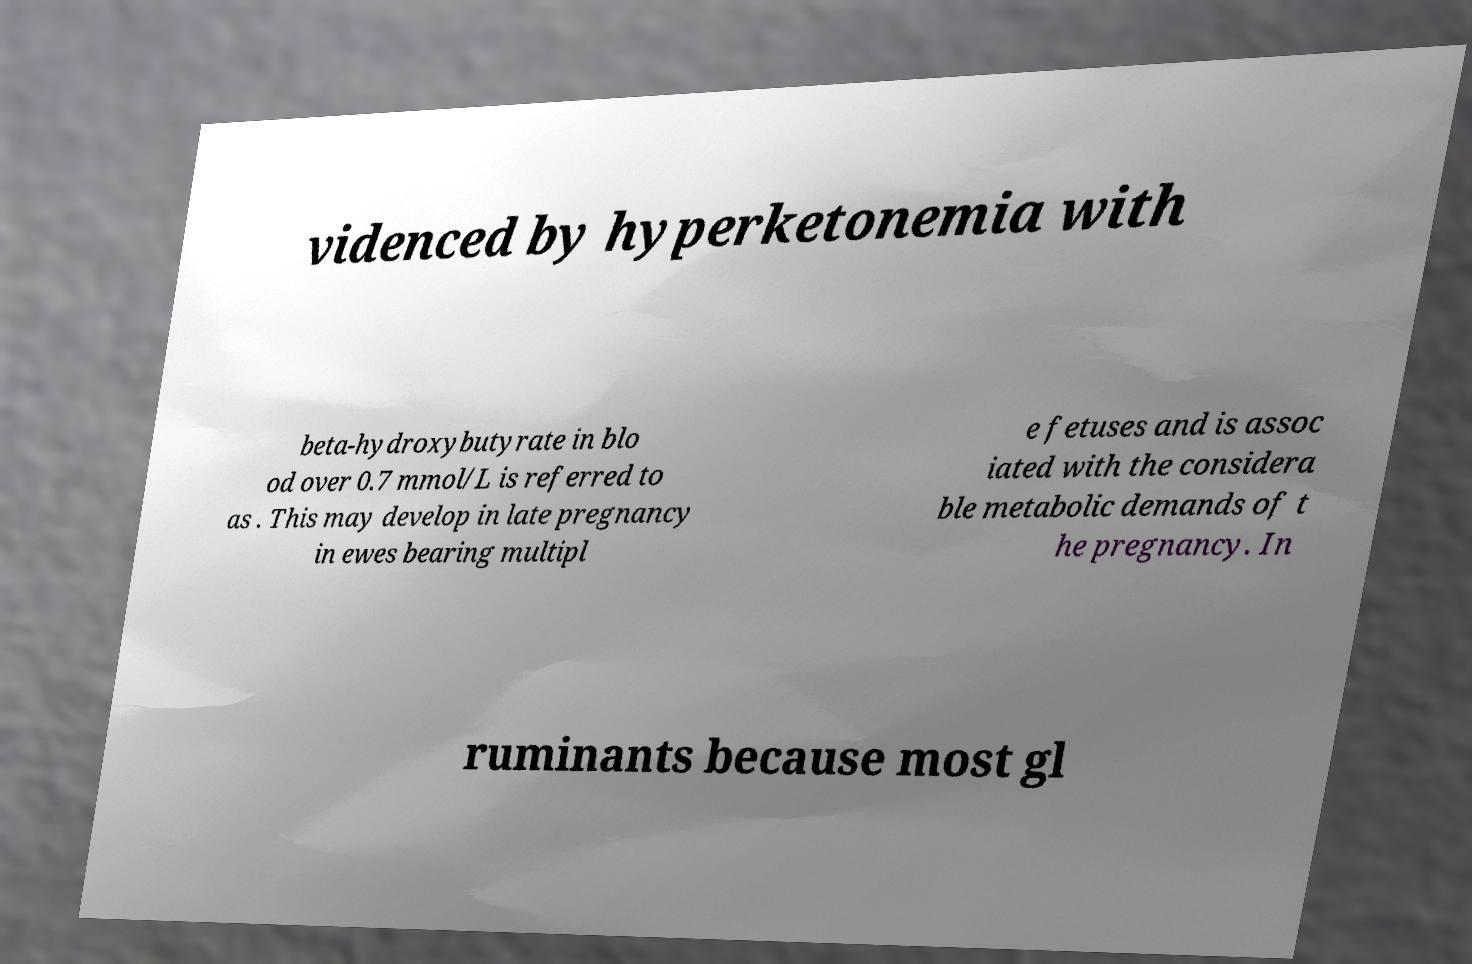What messages or text are displayed in this image? I need them in a readable, typed format. videnced by hyperketonemia with beta-hydroxybutyrate in blo od over 0.7 mmol/L is referred to as . This may develop in late pregnancy in ewes bearing multipl e fetuses and is assoc iated with the considera ble metabolic demands of t he pregnancy. In ruminants because most gl 